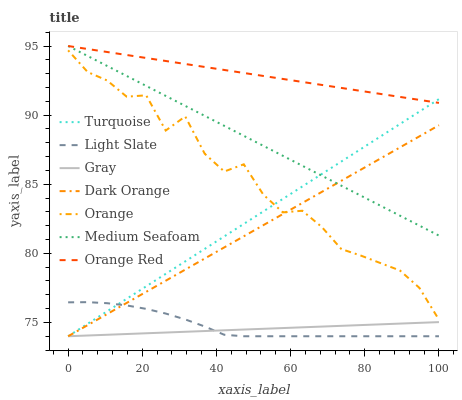Does Gray have the minimum area under the curve?
Answer yes or no. Yes. Does Orange Red have the maximum area under the curve?
Answer yes or no. Yes. Does Turquoise have the minimum area under the curve?
Answer yes or no. No. Does Turquoise have the maximum area under the curve?
Answer yes or no. No. Is Dark Orange the smoothest?
Answer yes or no. Yes. Is Orange the roughest?
Answer yes or no. Yes. Is Turquoise the smoothest?
Answer yes or no. No. Is Turquoise the roughest?
Answer yes or no. No. Does Gray have the lowest value?
Answer yes or no. Yes. Does Orange Red have the lowest value?
Answer yes or no. No. Does Medium Seafoam have the highest value?
Answer yes or no. Yes. Does Turquoise have the highest value?
Answer yes or no. No. Is Light Slate less than Orange Red?
Answer yes or no. Yes. Is Orange Red greater than Dark Orange?
Answer yes or no. Yes. Does Dark Orange intersect Medium Seafoam?
Answer yes or no. Yes. Is Dark Orange less than Medium Seafoam?
Answer yes or no. No. Is Dark Orange greater than Medium Seafoam?
Answer yes or no. No. Does Light Slate intersect Orange Red?
Answer yes or no. No. 